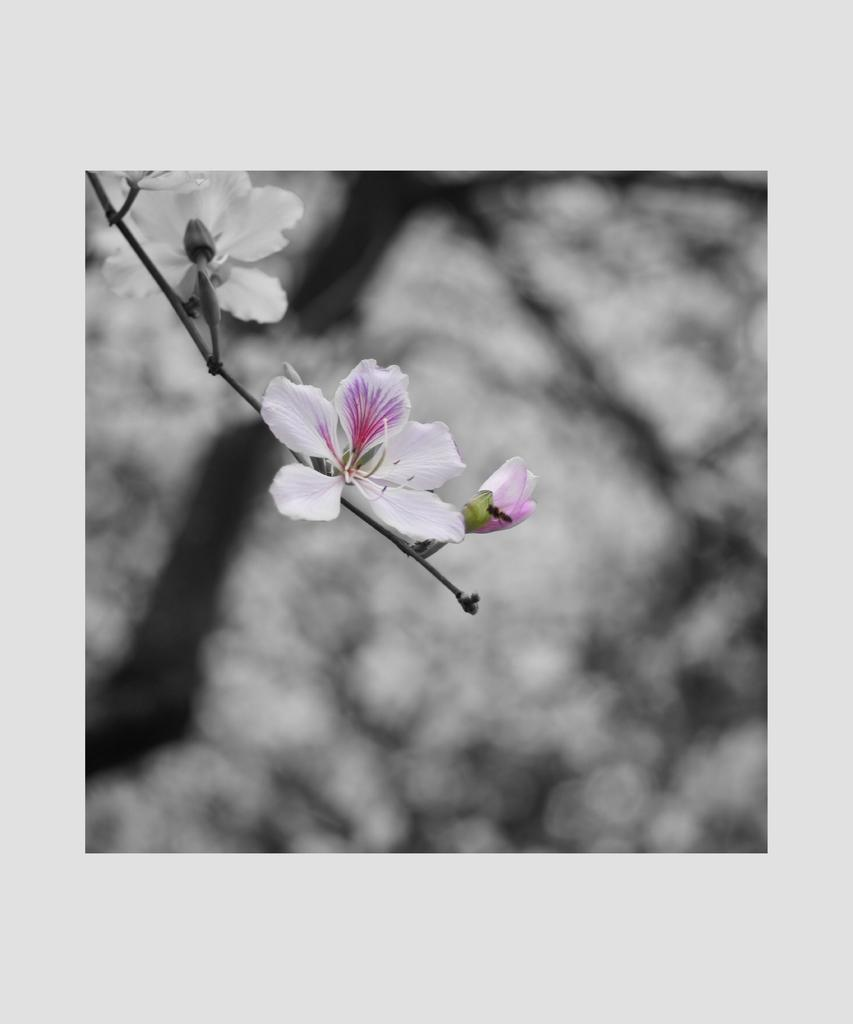What type of flowers can be seen in the image? There are white color flowers in the image. Where are the flowers located? The flowers are on a branch. What can be seen in the background of the image? There is a background in the image that might be a tree or plant. How many pears are hanging from the tin in the image? There are no pears or tins present in the image; it features white color flowers on a branch with a background that might be a tree or plant. 